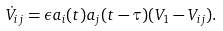Convert formula to latex. <formula><loc_0><loc_0><loc_500><loc_500>\dot { V } _ { i j } = \epsilon a _ { i } ( t ) a _ { j } ( t - \tau ) ( V _ { 1 } - V _ { i j } ) .</formula> 